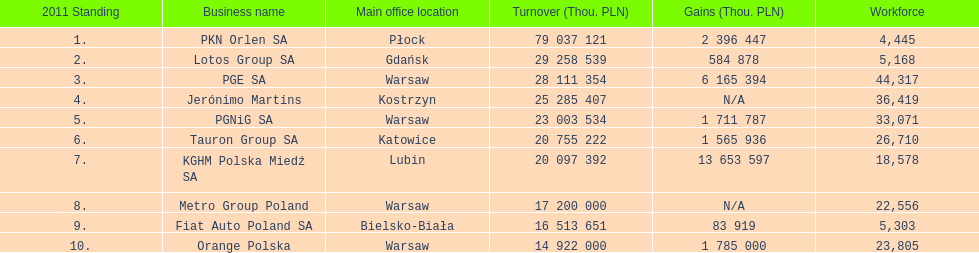What are the names of all the concerns? PKN Orlen SA, Lotos Group SA, PGE SA, Jerónimo Martins, PGNiG SA, Tauron Group SA, KGHM Polska Miedź SA, Metro Group Poland, Fiat Auto Poland SA, Orange Polska. How many employees does pgnig sa have? 33,071. 